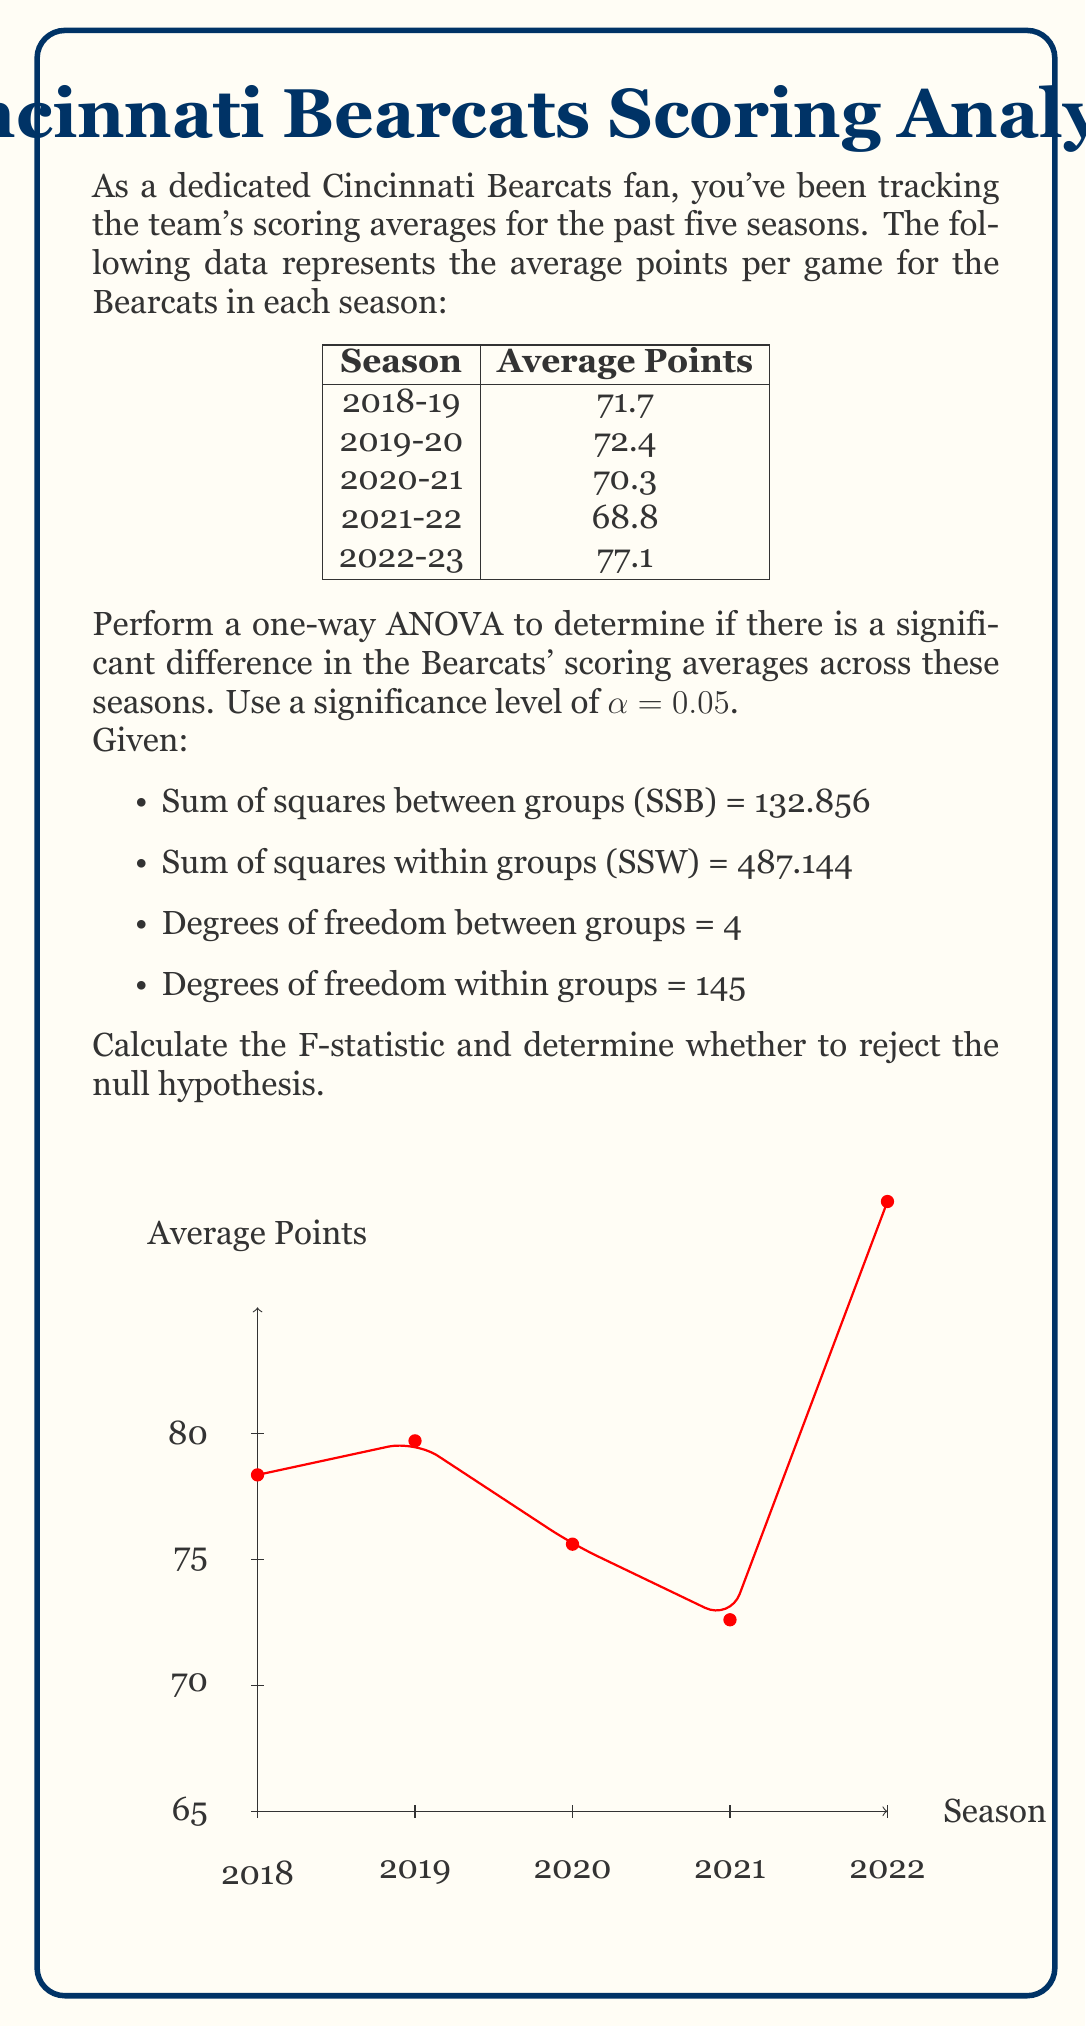What is the answer to this math problem? Let's approach this step-by-step:

1) First, we need to calculate the mean square between groups (MSB) and mean square within groups (MSW):

   MSB = SSB / df_between = 132.856 / 4 = 33.214
   MSW = SSW / df_within = 487.144 / 145 = 3.3596

2) The F-statistic is calculated as:

   $$F = \frac{MSB}{MSW} = \frac{33.214}{3.3596} = 9.8863$$

3) To determine whether to reject the null hypothesis, we need to compare this F-statistic with the critical F-value.

4) The critical F-value for α = 0.05, with df_between = 4 and df_within = 145, is approximately 2.43 (this can be found in an F-distribution table or calculated using software).

5) Since our calculated F-statistic (9.8863) is greater than the critical F-value (2.43), we reject the null hypothesis.

6) Interpretation: There is strong evidence to suggest that there are significant differences in the Bearcats' scoring averages across these five seasons.
Answer: $F = 9.8863$; Reject null hypothesis 